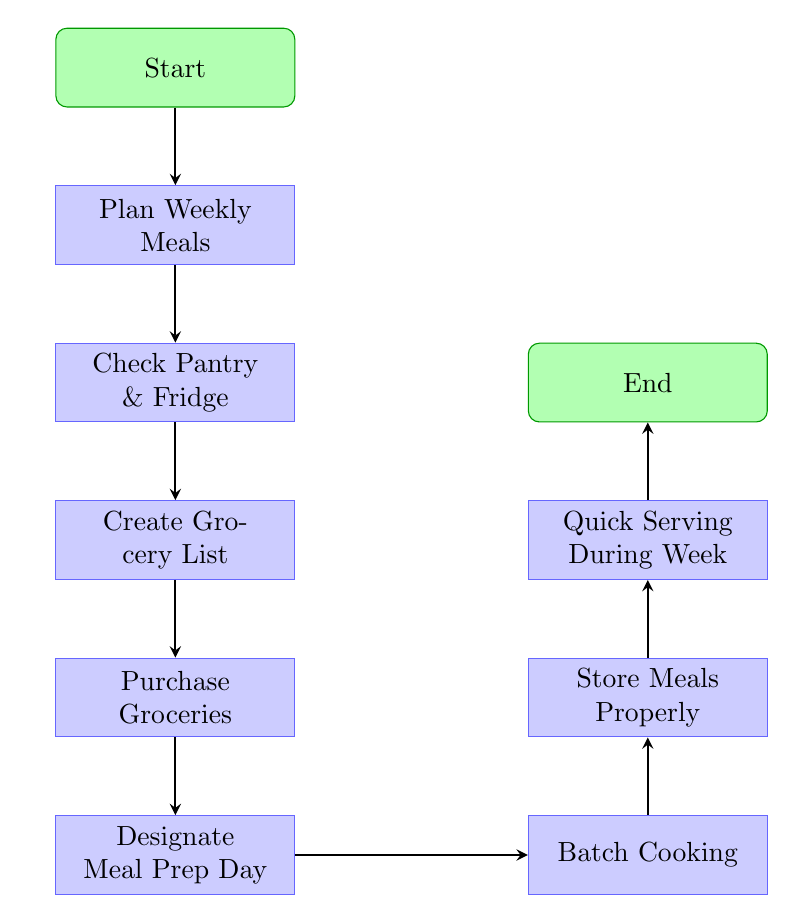What is the first step in the meal preparation workflow? The first node in the flow chart is labeled "Start", indicating it is the initial step of the process.
Answer: Start How many total nodes are in the diagram? By counting each labeled step, there are a total of 9 nodes, including both the starting and ending points.
Answer: 9 What is the last action before "End"? The action just before the "End" node is labeled "Quick Serving During Week," indicating what needs to be done right before completing the process.
Answer: Quick Serving During Week Which node follows "Plan Weekly Meals"? The next node in the sequence after "Plan Weekly Meals" is "Check Pantry & Fridge", showing the flow from planning to checking inventory.
Answer: Check Pantry & Fridge What is the relationship between "Batch Cooking" and "Store Meals Properly"? "Batch Cooking" is connected directly to "Store Meals Properly," meaning that after cooking in batches, the meals must be stored properly for later use.
Answer: Direct connection What step comes after "Purchase Groceries"? The step that follows "Purchase Groceries" is "Designate Meal Prep Day", indicating that after shopping, one should set aside a day for meal prep.
Answer: Designate Meal Prep Day How many connections are in the diagram? Each node connects to the next one, totaling 8 connections from the starting point to the end point.
Answer: 8 What process involves managing cooked meals? The node labeled "Store Meals Properly" specifically addresses the management of meals that have already been cooked.
Answer: Store Meals Properly 